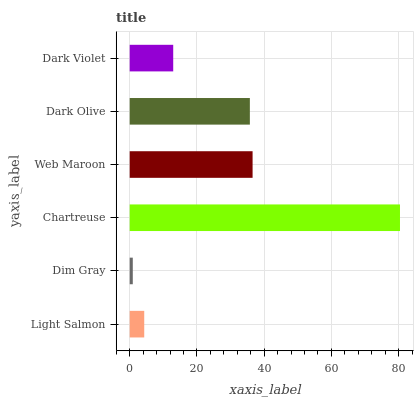Is Dim Gray the minimum?
Answer yes or no. Yes. Is Chartreuse the maximum?
Answer yes or no. Yes. Is Chartreuse the minimum?
Answer yes or no. No. Is Dim Gray the maximum?
Answer yes or no. No. Is Chartreuse greater than Dim Gray?
Answer yes or no. Yes. Is Dim Gray less than Chartreuse?
Answer yes or no. Yes. Is Dim Gray greater than Chartreuse?
Answer yes or no. No. Is Chartreuse less than Dim Gray?
Answer yes or no. No. Is Dark Olive the high median?
Answer yes or no. Yes. Is Dark Violet the low median?
Answer yes or no. Yes. Is Chartreuse the high median?
Answer yes or no. No. Is Dark Olive the low median?
Answer yes or no. No. 